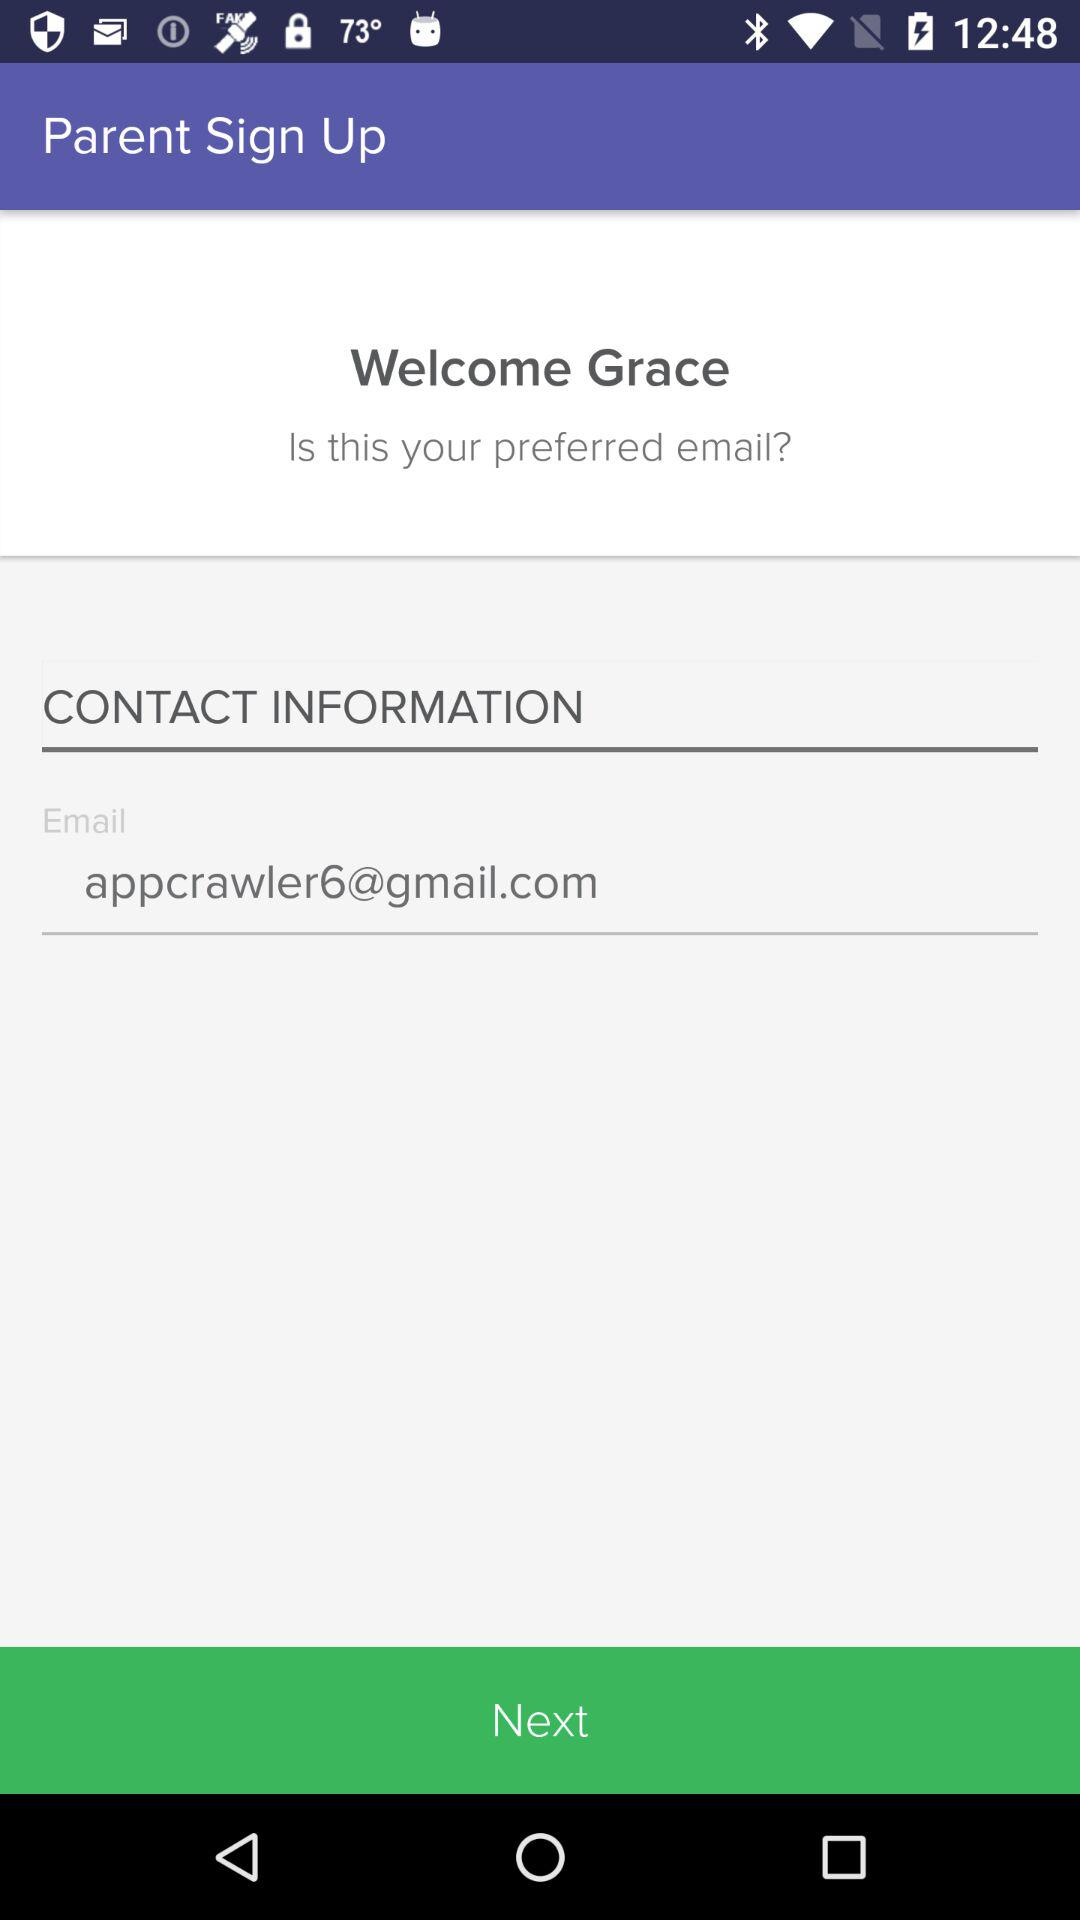What is the email address? The email address is appcrawler6@gmail.com. 